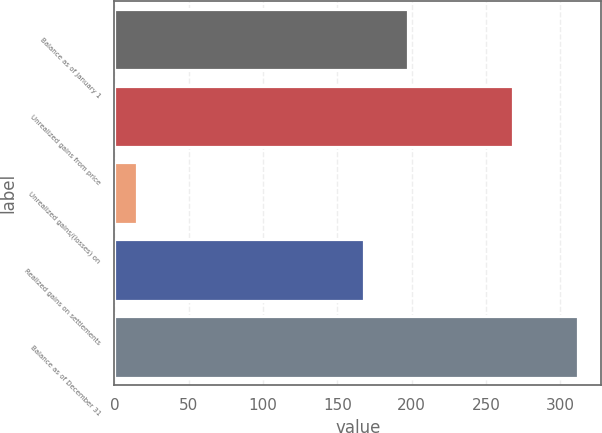Convert chart to OTSL. <chart><loc_0><loc_0><loc_500><loc_500><bar_chart><fcel>Balance as of January 1<fcel>Unrealized gains from price<fcel>Unrealized gains/(losses) on<fcel>Realized gains on settlements<fcel>Balance as of December 31<nl><fcel>197.7<fcel>268<fcel>15<fcel>168<fcel>312<nl></chart> 